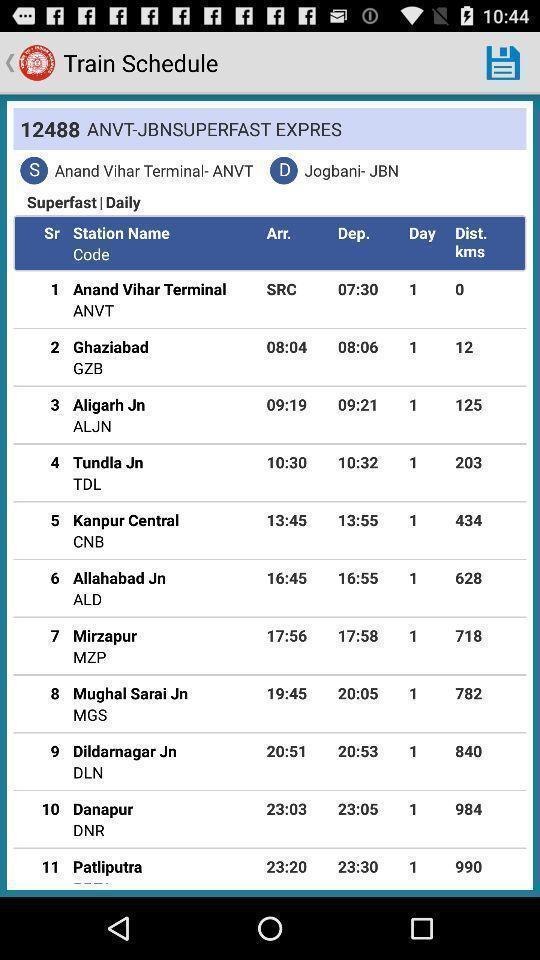Give me a narrative description of this picture. Page showing train schedule. 